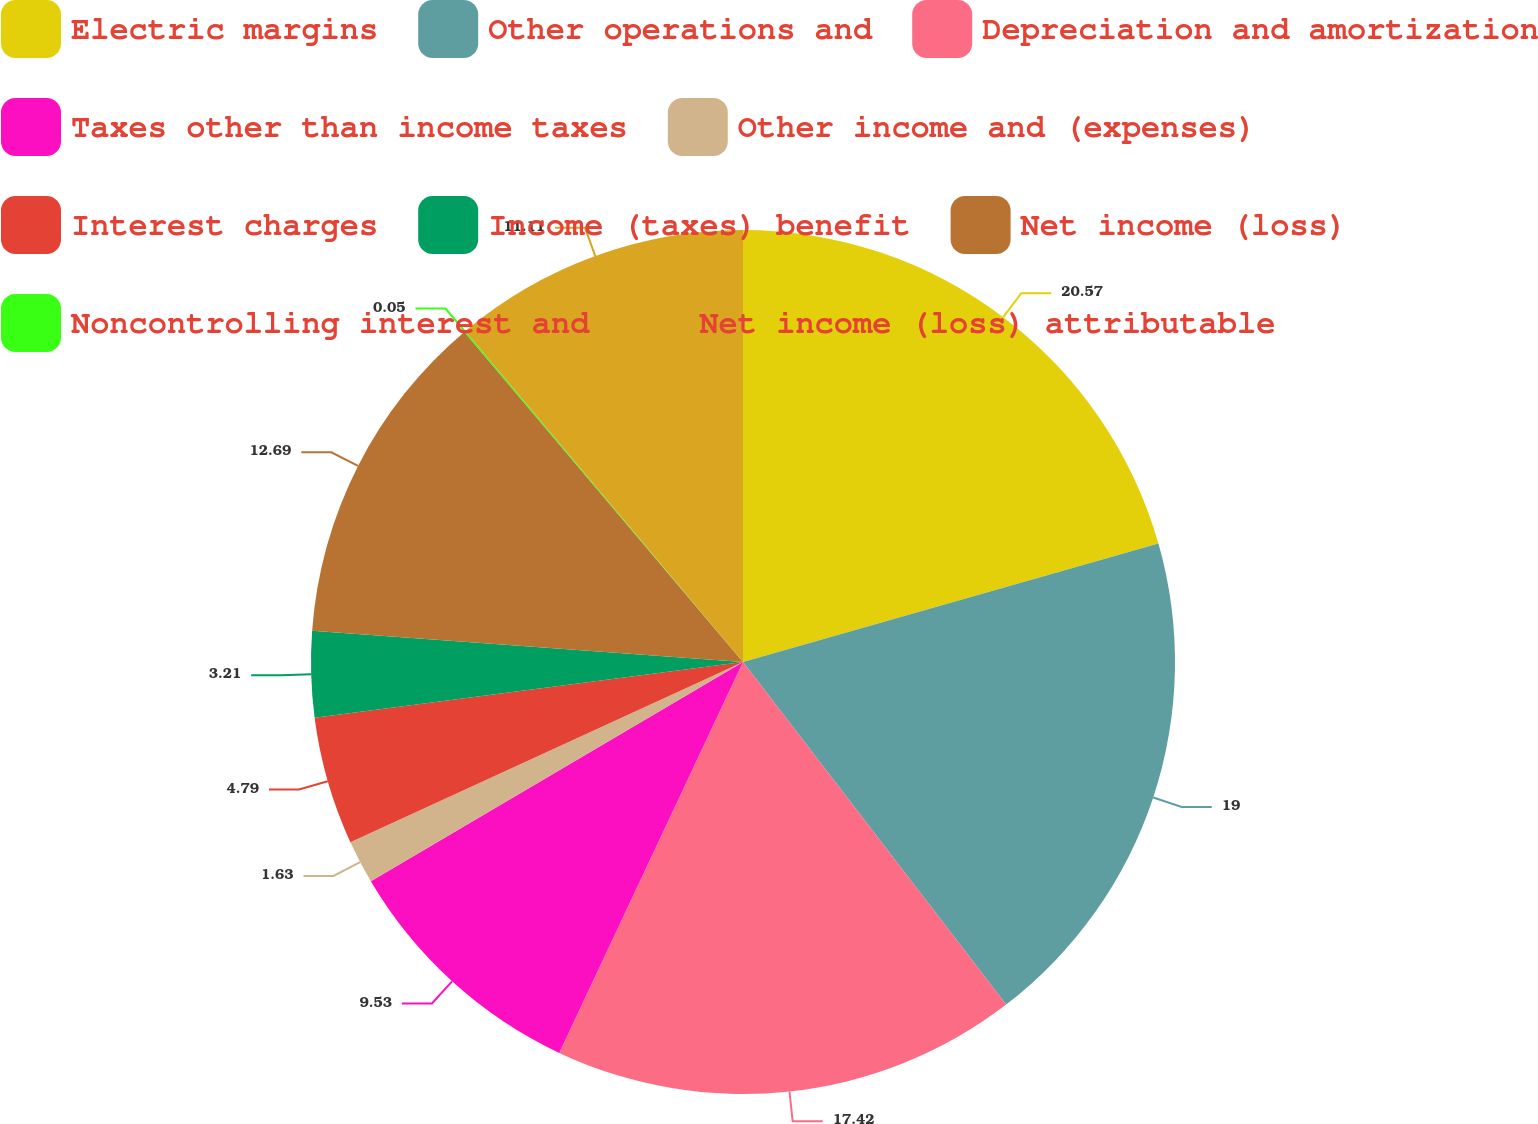Convert chart to OTSL. <chart><loc_0><loc_0><loc_500><loc_500><pie_chart><fcel>Electric margins<fcel>Other operations and<fcel>Depreciation and amortization<fcel>Taxes other than income taxes<fcel>Other income and (expenses)<fcel>Interest charges<fcel>Income (taxes) benefit<fcel>Net income (loss)<fcel>Noncontrolling interest and<fcel>Net income (loss) attributable<nl><fcel>20.58%<fcel>19.0%<fcel>17.42%<fcel>9.53%<fcel>1.63%<fcel>4.79%<fcel>3.21%<fcel>12.69%<fcel>0.05%<fcel>11.11%<nl></chart> 